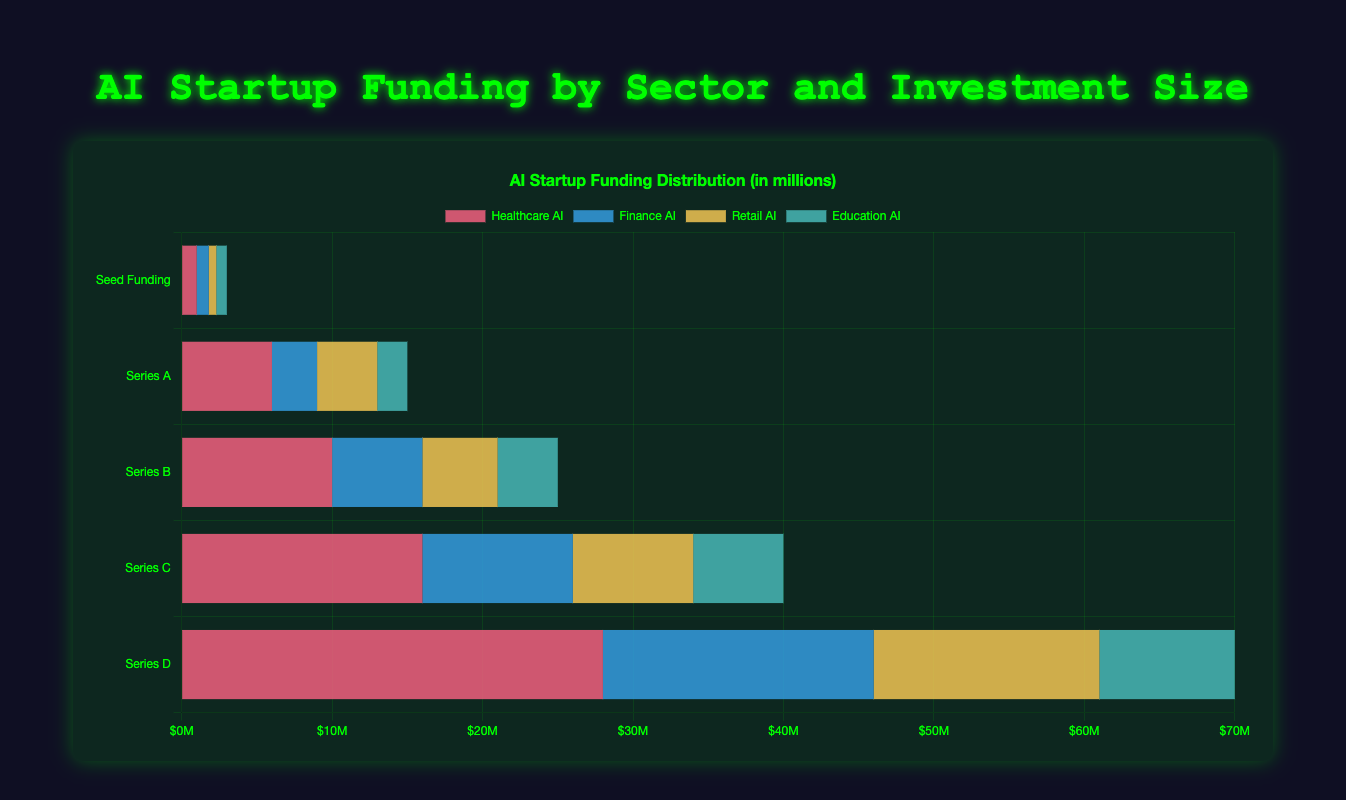What is the total amount of funding received by Healthcare AI across all investment sizes? Sum the amounts of Healthcare AI funding from each investment size: 1M (Seed) + 6M (Series A) + 10M (Series B) + 16M (Series C) + 28M (Series D) = 61M
Answer: 61M Which investment size has the highest amount of funding for Finance AI? Look for the investment size with the largest value in the Finance AI sector: Finance AI receives 18M in Series D, which is the highest compared to other sizes.
Answer: Series D What is the difference in funding between Retail AI and Education AI in Series B? Subtract the amount for Education AI from Retail AI in Series B: 5M (Retail AI) - 4M (Education AI) = 1M
Answer: 1M How does the total funding of Series A compare to Series B for all sectors combined? Compare the total amounts from each investment size: Series A has 15M and Series B has 25M, thus Series B receives 10M more
Answer: Series B receives 10M more What is the color used to represent the Education AI sector in the chart? Identify the color associated with the Education AI bars, which are cyan (light blue).
Answer: cyan How much more funding does Series D provide to Healthcare AI compared to Series C? Subtract Healthcare AI funding in Series C from Series D: 28M (Series D) - 16M (Series C) = 12M
Answer: 12M Which sector receives the least amount of seed funding? From the Seed Funding amounts, identify the lowest value: Retail AI receives 0.5M, which is the least
Answer: Retail AI What is the sum of funding received by all sectors in Series C? Sum up the values for all sectors in Series C: 16M (Healthcare AI) + 10M (Finance AI) + 8M (Retail AI) + 6M (Education AI) = 40M
Answer: 40M Between Finance AI and Retail AI, which has a higher total funding across all sizes? Calculate and compare the total funding: Finance AI has 58M (0.8 + 3 + 6 + 10 + 18), and Retail AI has 33M (0.5 + 4 + 5 + 8 + 15). Finance AI has higher total funding.
Answer: Finance AI Which investment size contributes the most to Retail AI funding? Identify the investment size with the highest Retail AI funding: Series D funds 15M to Retail AI, which is the highest.
Answer: Series D 